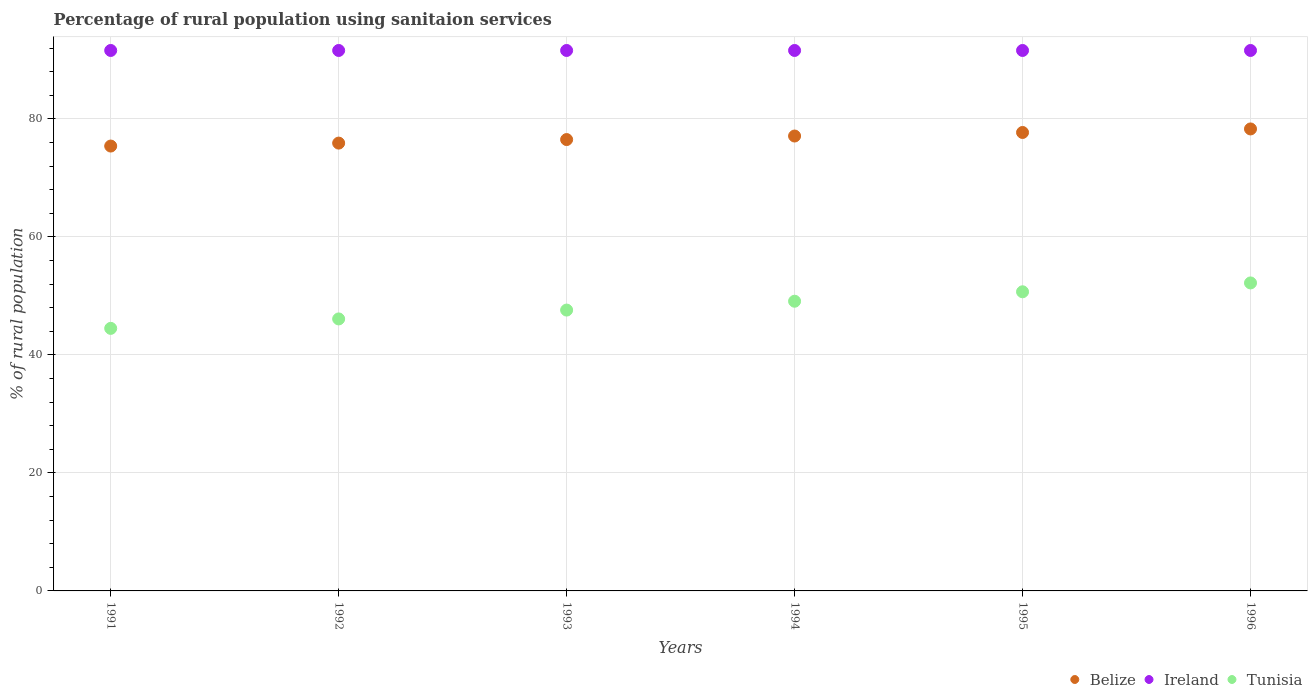What is the percentage of rural population using sanitaion services in Belize in 1992?
Offer a very short reply. 75.9. Across all years, what is the maximum percentage of rural population using sanitaion services in Tunisia?
Provide a short and direct response. 52.2. Across all years, what is the minimum percentage of rural population using sanitaion services in Belize?
Make the answer very short. 75.4. In which year was the percentage of rural population using sanitaion services in Belize maximum?
Keep it short and to the point. 1996. In which year was the percentage of rural population using sanitaion services in Belize minimum?
Ensure brevity in your answer.  1991. What is the total percentage of rural population using sanitaion services in Belize in the graph?
Provide a succinct answer. 460.9. What is the difference between the percentage of rural population using sanitaion services in Belize in 1992 and that in 1995?
Make the answer very short. -1.8. What is the difference between the percentage of rural population using sanitaion services in Ireland in 1993 and the percentage of rural population using sanitaion services in Belize in 1992?
Ensure brevity in your answer.  15.7. What is the average percentage of rural population using sanitaion services in Ireland per year?
Your answer should be very brief. 91.6. In the year 1991, what is the difference between the percentage of rural population using sanitaion services in Tunisia and percentage of rural population using sanitaion services in Ireland?
Give a very brief answer. -47.1. In how many years, is the percentage of rural population using sanitaion services in Ireland greater than 56 %?
Provide a succinct answer. 6. What is the ratio of the percentage of rural population using sanitaion services in Tunisia in 1991 to that in 1996?
Offer a very short reply. 0.85. Is the percentage of rural population using sanitaion services in Ireland in 1991 less than that in 1994?
Provide a short and direct response. No. Is the difference between the percentage of rural population using sanitaion services in Tunisia in 1993 and 1996 greater than the difference between the percentage of rural population using sanitaion services in Ireland in 1993 and 1996?
Ensure brevity in your answer.  No. What is the difference between the highest and the second highest percentage of rural population using sanitaion services in Belize?
Your response must be concise. 0.6. What is the difference between the highest and the lowest percentage of rural population using sanitaion services in Ireland?
Provide a succinct answer. 0. In how many years, is the percentage of rural population using sanitaion services in Ireland greater than the average percentage of rural population using sanitaion services in Ireland taken over all years?
Make the answer very short. 0. Is it the case that in every year, the sum of the percentage of rural population using sanitaion services in Ireland and percentage of rural population using sanitaion services in Belize  is greater than the percentage of rural population using sanitaion services in Tunisia?
Your response must be concise. Yes. Does the percentage of rural population using sanitaion services in Ireland monotonically increase over the years?
Keep it short and to the point. No. Is the percentage of rural population using sanitaion services in Ireland strictly greater than the percentage of rural population using sanitaion services in Tunisia over the years?
Provide a short and direct response. Yes. How many dotlines are there?
Offer a terse response. 3. Are the values on the major ticks of Y-axis written in scientific E-notation?
Make the answer very short. No. Does the graph contain grids?
Ensure brevity in your answer.  Yes. How are the legend labels stacked?
Offer a very short reply. Horizontal. What is the title of the graph?
Provide a short and direct response. Percentage of rural population using sanitaion services. What is the label or title of the Y-axis?
Your answer should be very brief. % of rural population. What is the % of rural population of Belize in 1991?
Provide a short and direct response. 75.4. What is the % of rural population in Ireland in 1991?
Ensure brevity in your answer.  91.6. What is the % of rural population of Tunisia in 1991?
Keep it short and to the point. 44.5. What is the % of rural population of Belize in 1992?
Ensure brevity in your answer.  75.9. What is the % of rural population in Ireland in 1992?
Keep it short and to the point. 91.6. What is the % of rural population of Tunisia in 1992?
Your response must be concise. 46.1. What is the % of rural population in Belize in 1993?
Your answer should be very brief. 76.5. What is the % of rural population of Ireland in 1993?
Offer a terse response. 91.6. What is the % of rural population of Tunisia in 1993?
Offer a terse response. 47.6. What is the % of rural population in Belize in 1994?
Give a very brief answer. 77.1. What is the % of rural population in Ireland in 1994?
Your answer should be compact. 91.6. What is the % of rural population in Tunisia in 1994?
Keep it short and to the point. 49.1. What is the % of rural population in Belize in 1995?
Give a very brief answer. 77.7. What is the % of rural population in Ireland in 1995?
Offer a very short reply. 91.6. What is the % of rural population of Tunisia in 1995?
Offer a terse response. 50.7. What is the % of rural population in Belize in 1996?
Offer a very short reply. 78.3. What is the % of rural population of Ireland in 1996?
Your answer should be compact. 91.6. What is the % of rural population in Tunisia in 1996?
Offer a terse response. 52.2. Across all years, what is the maximum % of rural population of Belize?
Offer a very short reply. 78.3. Across all years, what is the maximum % of rural population in Ireland?
Ensure brevity in your answer.  91.6. Across all years, what is the maximum % of rural population of Tunisia?
Provide a short and direct response. 52.2. Across all years, what is the minimum % of rural population of Belize?
Your answer should be very brief. 75.4. Across all years, what is the minimum % of rural population in Ireland?
Keep it short and to the point. 91.6. Across all years, what is the minimum % of rural population of Tunisia?
Your answer should be compact. 44.5. What is the total % of rural population in Belize in the graph?
Offer a very short reply. 460.9. What is the total % of rural population in Ireland in the graph?
Make the answer very short. 549.6. What is the total % of rural population in Tunisia in the graph?
Your answer should be very brief. 290.2. What is the difference between the % of rural population in Belize in 1991 and that in 1992?
Your response must be concise. -0.5. What is the difference between the % of rural population of Belize in 1991 and that in 1993?
Provide a succinct answer. -1.1. What is the difference between the % of rural population of Ireland in 1991 and that in 1993?
Offer a terse response. 0. What is the difference between the % of rural population of Belize in 1991 and that in 1994?
Ensure brevity in your answer.  -1.7. What is the difference between the % of rural population in Tunisia in 1991 and that in 1995?
Your answer should be very brief. -6.2. What is the difference between the % of rural population of Ireland in 1991 and that in 1996?
Keep it short and to the point. 0. What is the difference between the % of rural population of Tunisia in 1991 and that in 1996?
Provide a succinct answer. -7.7. What is the difference between the % of rural population of Tunisia in 1992 and that in 1993?
Offer a terse response. -1.5. What is the difference between the % of rural population in Belize in 1992 and that in 1994?
Make the answer very short. -1.2. What is the difference between the % of rural population in Ireland in 1992 and that in 1994?
Your answer should be compact. 0. What is the difference between the % of rural population in Tunisia in 1992 and that in 1994?
Offer a very short reply. -3. What is the difference between the % of rural population of Belize in 1992 and that in 1995?
Your answer should be very brief. -1.8. What is the difference between the % of rural population of Ireland in 1992 and that in 1995?
Make the answer very short. 0. What is the difference between the % of rural population of Tunisia in 1992 and that in 1995?
Make the answer very short. -4.6. What is the difference between the % of rural population of Ireland in 1992 and that in 1996?
Offer a very short reply. 0. What is the difference between the % of rural population in Belize in 1993 and that in 1994?
Your response must be concise. -0.6. What is the difference between the % of rural population of Belize in 1993 and that in 1995?
Your response must be concise. -1.2. What is the difference between the % of rural population in Belize in 1993 and that in 1996?
Offer a terse response. -1.8. What is the difference between the % of rural population in Tunisia in 1993 and that in 1996?
Provide a succinct answer. -4.6. What is the difference between the % of rural population in Belize in 1994 and that in 1995?
Provide a short and direct response. -0.6. What is the difference between the % of rural population in Ireland in 1994 and that in 1995?
Give a very brief answer. 0. What is the difference between the % of rural population of Belize in 1995 and that in 1996?
Offer a terse response. -0.6. What is the difference between the % of rural population in Belize in 1991 and the % of rural population in Ireland in 1992?
Provide a short and direct response. -16.2. What is the difference between the % of rural population of Belize in 1991 and the % of rural population of Tunisia in 1992?
Your response must be concise. 29.3. What is the difference between the % of rural population in Ireland in 1991 and the % of rural population in Tunisia in 1992?
Offer a terse response. 45.5. What is the difference between the % of rural population of Belize in 1991 and the % of rural population of Ireland in 1993?
Your answer should be compact. -16.2. What is the difference between the % of rural population in Belize in 1991 and the % of rural population in Tunisia in 1993?
Make the answer very short. 27.8. What is the difference between the % of rural population of Ireland in 1991 and the % of rural population of Tunisia in 1993?
Your answer should be very brief. 44. What is the difference between the % of rural population in Belize in 1991 and the % of rural population in Ireland in 1994?
Your response must be concise. -16.2. What is the difference between the % of rural population in Belize in 1991 and the % of rural population in Tunisia in 1994?
Your answer should be very brief. 26.3. What is the difference between the % of rural population in Ireland in 1991 and the % of rural population in Tunisia in 1994?
Provide a succinct answer. 42.5. What is the difference between the % of rural population in Belize in 1991 and the % of rural population in Ireland in 1995?
Your response must be concise. -16.2. What is the difference between the % of rural population in Belize in 1991 and the % of rural population in Tunisia in 1995?
Your response must be concise. 24.7. What is the difference between the % of rural population in Ireland in 1991 and the % of rural population in Tunisia in 1995?
Keep it short and to the point. 40.9. What is the difference between the % of rural population of Belize in 1991 and the % of rural population of Ireland in 1996?
Give a very brief answer. -16.2. What is the difference between the % of rural population in Belize in 1991 and the % of rural population in Tunisia in 1996?
Make the answer very short. 23.2. What is the difference between the % of rural population in Ireland in 1991 and the % of rural population in Tunisia in 1996?
Your answer should be compact. 39.4. What is the difference between the % of rural population in Belize in 1992 and the % of rural population in Ireland in 1993?
Keep it short and to the point. -15.7. What is the difference between the % of rural population in Belize in 1992 and the % of rural population in Tunisia in 1993?
Offer a terse response. 28.3. What is the difference between the % of rural population in Ireland in 1992 and the % of rural population in Tunisia in 1993?
Offer a very short reply. 44. What is the difference between the % of rural population of Belize in 1992 and the % of rural population of Ireland in 1994?
Offer a terse response. -15.7. What is the difference between the % of rural population in Belize in 1992 and the % of rural population in Tunisia in 1994?
Your answer should be very brief. 26.8. What is the difference between the % of rural population in Ireland in 1992 and the % of rural population in Tunisia in 1994?
Make the answer very short. 42.5. What is the difference between the % of rural population in Belize in 1992 and the % of rural population in Ireland in 1995?
Give a very brief answer. -15.7. What is the difference between the % of rural population in Belize in 1992 and the % of rural population in Tunisia in 1995?
Your response must be concise. 25.2. What is the difference between the % of rural population of Ireland in 1992 and the % of rural population of Tunisia in 1995?
Give a very brief answer. 40.9. What is the difference between the % of rural population in Belize in 1992 and the % of rural population in Ireland in 1996?
Offer a very short reply. -15.7. What is the difference between the % of rural population in Belize in 1992 and the % of rural population in Tunisia in 1996?
Provide a succinct answer. 23.7. What is the difference between the % of rural population in Ireland in 1992 and the % of rural population in Tunisia in 1996?
Keep it short and to the point. 39.4. What is the difference between the % of rural population of Belize in 1993 and the % of rural population of Ireland in 1994?
Offer a very short reply. -15.1. What is the difference between the % of rural population in Belize in 1993 and the % of rural population in Tunisia in 1994?
Offer a very short reply. 27.4. What is the difference between the % of rural population of Ireland in 1993 and the % of rural population of Tunisia in 1994?
Give a very brief answer. 42.5. What is the difference between the % of rural population of Belize in 1993 and the % of rural population of Ireland in 1995?
Your response must be concise. -15.1. What is the difference between the % of rural population of Belize in 1993 and the % of rural population of Tunisia in 1995?
Provide a short and direct response. 25.8. What is the difference between the % of rural population of Ireland in 1993 and the % of rural population of Tunisia in 1995?
Offer a terse response. 40.9. What is the difference between the % of rural population of Belize in 1993 and the % of rural population of Ireland in 1996?
Keep it short and to the point. -15.1. What is the difference between the % of rural population in Belize in 1993 and the % of rural population in Tunisia in 1996?
Your answer should be compact. 24.3. What is the difference between the % of rural population of Ireland in 1993 and the % of rural population of Tunisia in 1996?
Keep it short and to the point. 39.4. What is the difference between the % of rural population in Belize in 1994 and the % of rural population in Ireland in 1995?
Your answer should be compact. -14.5. What is the difference between the % of rural population of Belize in 1994 and the % of rural population of Tunisia in 1995?
Your answer should be very brief. 26.4. What is the difference between the % of rural population of Ireland in 1994 and the % of rural population of Tunisia in 1995?
Keep it short and to the point. 40.9. What is the difference between the % of rural population in Belize in 1994 and the % of rural population in Tunisia in 1996?
Keep it short and to the point. 24.9. What is the difference between the % of rural population of Ireland in 1994 and the % of rural population of Tunisia in 1996?
Offer a terse response. 39.4. What is the difference between the % of rural population of Belize in 1995 and the % of rural population of Ireland in 1996?
Offer a terse response. -13.9. What is the difference between the % of rural population of Belize in 1995 and the % of rural population of Tunisia in 1996?
Make the answer very short. 25.5. What is the difference between the % of rural population of Ireland in 1995 and the % of rural population of Tunisia in 1996?
Provide a succinct answer. 39.4. What is the average % of rural population in Belize per year?
Make the answer very short. 76.82. What is the average % of rural population of Ireland per year?
Provide a succinct answer. 91.6. What is the average % of rural population of Tunisia per year?
Keep it short and to the point. 48.37. In the year 1991, what is the difference between the % of rural population of Belize and % of rural population of Ireland?
Your answer should be compact. -16.2. In the year 1991, what is the difference between the % of rural population of Belize and % of rural population of Tunisia?
Offer a terse response. 30.9. In the year 1991, what is the difference between the % of rural population in Ireland and % of rural population in Tunisia?
Provide a short and direct response. 47.1. In the year 1992, what is the difference between the % of rural population in Belize and % of rural population in Ireland?
Keep it short and to the point. -15.7. In the year 1992, what is the difference between the % of rural population in Belize and % of rural population in Tunisia?
Your answer should be very brief. 29.8. In the year 1992, what is the difference between the % of rural population of Ireland and % of rural population of Tunisia?
Offer a very short reply. 45.5. In the year 1993, what is the difference between the % of rural population in Belize and % of rural population in Ireland?
Offer a very short reply. -15.1. In the year 1993, what is the difference between the % of rural population of Belize and % of rural population of Tunisia?
Your answer should be compact. 28.9. In the year 1994, what is the difference between the % of rural population in Belize and % of rural population in Ireland?
Ensure brevity in your answer.  -14.5. In the year 1994, what is the difference between the % of rural population in Belize and % of rural population in Tunisia?
Offer a terse response. 28. In the year 1994, what is the difference between the % of rural population of Ireland and % of rural population of Tunisia?
Give a very brief answer. 42.5. In the year 1995, what is the difference between the % of rural population of Belize and % of rural population of Tunisia?
Ensure brevity in your answer.  27. In the year 1995, what is the difference between the % of rural population in Ireland and % of rural population in Tunisia?
Keep it short and to the point. 40.9. In the year 1996, what is the difference between the % of rural population in Belize and % of rural population in Ireland?
Your response must be concise. -13.3. In the year 1996, what is the difference between the % of rural population of Belize and % of rural population of Tunisia?
Give a very brief answer. 26.1. In the year 1996, what is the difference between the % of rural population in Ireland and % of rural population in Tunisia?
Make the answer very short. 39.4. What is the ratio of the % of rural population in Belize in 1991 to that in 1992?
Your answer should be compact. 0.99. What is the ratio of the % of rural population of Ireland in 1991 to that in 1992?
Give a very brief answer. 1. What is the ratio of the % of rural population of Tunisia in 1991 to that in 1992?
Provide a short and direct response. 0.97. What is the ratio of the % of rural population in Belize in 1991 to that in 1993?
Ensure brevity in your answer.  0.99. What is the ratio of the % of rural population of Tunisia in 1991 to that in 1993?
Provide a short and direct response. 0.93. What is the ratio of the % of rural population in Ireland in 1991 to that in 1994?
Provide a succinct answer. 1. What is the ratio of the % of rural population in Tunisia in 1991 to that in 1994?
Give a very brief answer. 0.91. What is the ratio of the % of rural population in Belize in 1991 to that in 1995?
Provide a short and direct response. 0.97. What is the ratio of the % of rural population of Ireland in 1991 to that in 1995?
Offer a very short reply. 1. What is the ratio of the % of rural population in Tunisia in 1991 to that in 1995?
Your answer should be compact. 0.88. What is the ratio of the % of rural population of Ireland in 1991 to that in 1996?
Provide a short and direct response. 1. What is the ratio of the % of rural population of Tunisia in 1991 to that in 1996?
Ensure brevity in your answer.  0.85. What is the ratio of the % of rural population in Belize in 1992 to that in 1993?
Provide a succinct answer. 0.99. What is the ratio of the % of rural population in Tunisia in 1992 to that in 1993?
Provide a short and direct response. 0.97. What is the ratio of the % of rural population of Belize in 1992 to that in 1994?
Your answer should be very brief. 0.98. What is the ratio of the % of rural population in Ireland in 1992 to that in 1994?
Ensure brevity in your answer.  1. What is the ratio of the % of rural population of Tunisia in 1992 to that in 1994?
Make the answer very short. 0.94. What is the ratio of the % of rural population in Belize in 1992 to that in 1995?
Provide a short and direct response. 0.98. What is the ratio of the % of rural population of Tunisia in 1992 to that in 1995?
Your response must be concise. 0.91. What is the ratio of the % of rural population in Belize in 1992 to that in 1996?
Your answer should be compact. 0.97. What is the ratio of the % of rural population in Ireland in 1992 to that in 1996?
Offer a terse response. 1. What is the ratio of the % of rural population of Tunisia in 1992 to that in 1996?
Ensure brevity in your answer.  0.88. What is the ratio of the % of rural population of Belize in 1993 to that in 1994?
Ensure brevity in your answer.  0.99. What is the ratio of the % of rural population in Tunisia in 1993 to that in 1994?
Keep it short and to the point. 0.97. What is the ratio of the % of rural population in Belize in 1993 to that in 1995?
Ensure brevity in your answer.  0.98. What is the ratio of the % of rural population of Tunisia in 1993 to that in 1995?
Your response must be concise. 0.94. What is the ratio of the % of rural population of Ireland in 1993 to that in 1996?
Your answer should be very brief. 1. What is the ratio of the % of rural population of Tunisia in 1993 to that in 1996?
Offer a terse response. 0.91. What is the ratio of the % of rural population of Belize in 1994 to that in 1995?
Provide a short and direct response. 0.99. What is the ratio of the % of rural population of Ireland in 1994 to that in 1995?
Give a very brief answer. 1. What is the ratio of the % of rural population of Tunisia in 1994 to that in 1995?
Make the answer very short. 0.97. What is the ratio of the % of rural population in Belize in 1994 to that in 1996?
Keep it short and to the point. 0.98. What is the ratio of the % of rural population of Tunisia in 1994 to that in 1996?
Offer a terse response. 0.94. What is the ratio of the % of rural population of Ireland in 1995 to that in 1996?
Ensure brevity in your answer.  1. What is the ratio of the % of rural population in Tunisia in 1995 to that in 1996?
Ensure brevity in your answer.  0.97. What is the difference between the highest and the second highest % of rural population in Belize?
Ensure brevity in your answer.  0.6. What is the difference between the highest and the lowest % of rural population of Ireland?
Ensure brevity in your answer.  0. 